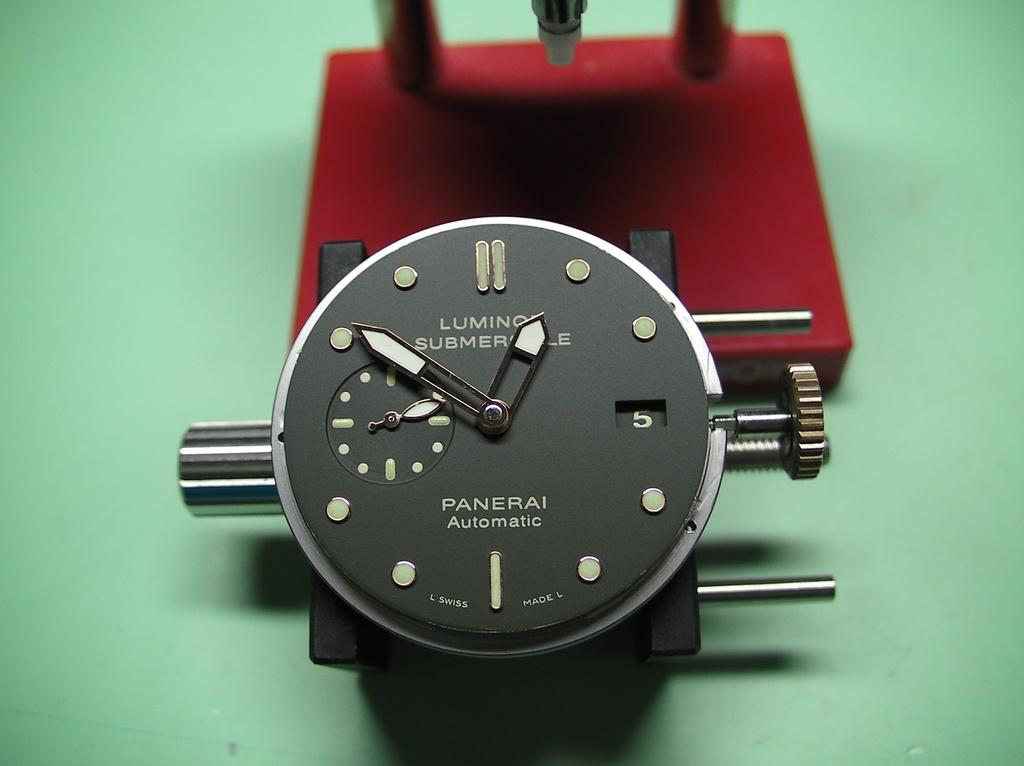<image>
Create a compact narrative representing the image presented. The Panerai watch face is displayed without the bezel or glass. 